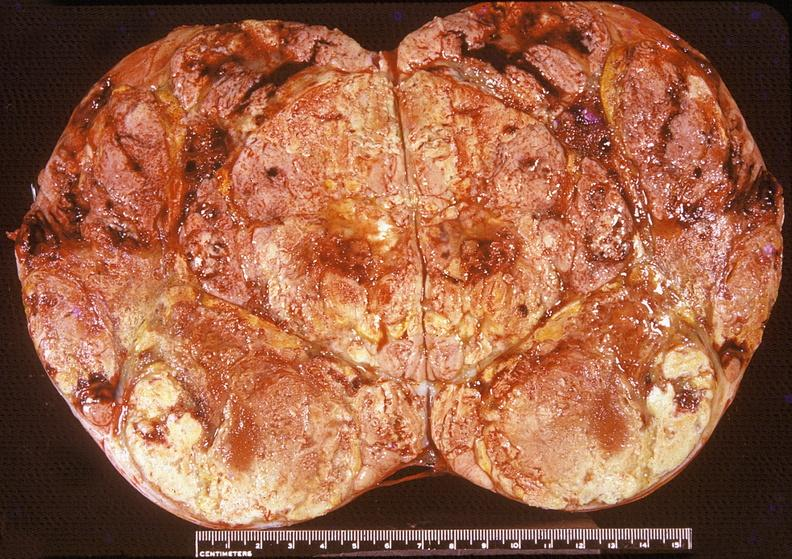where does this belong to?
Answer the question using a single word or phrase. Endocrine system 